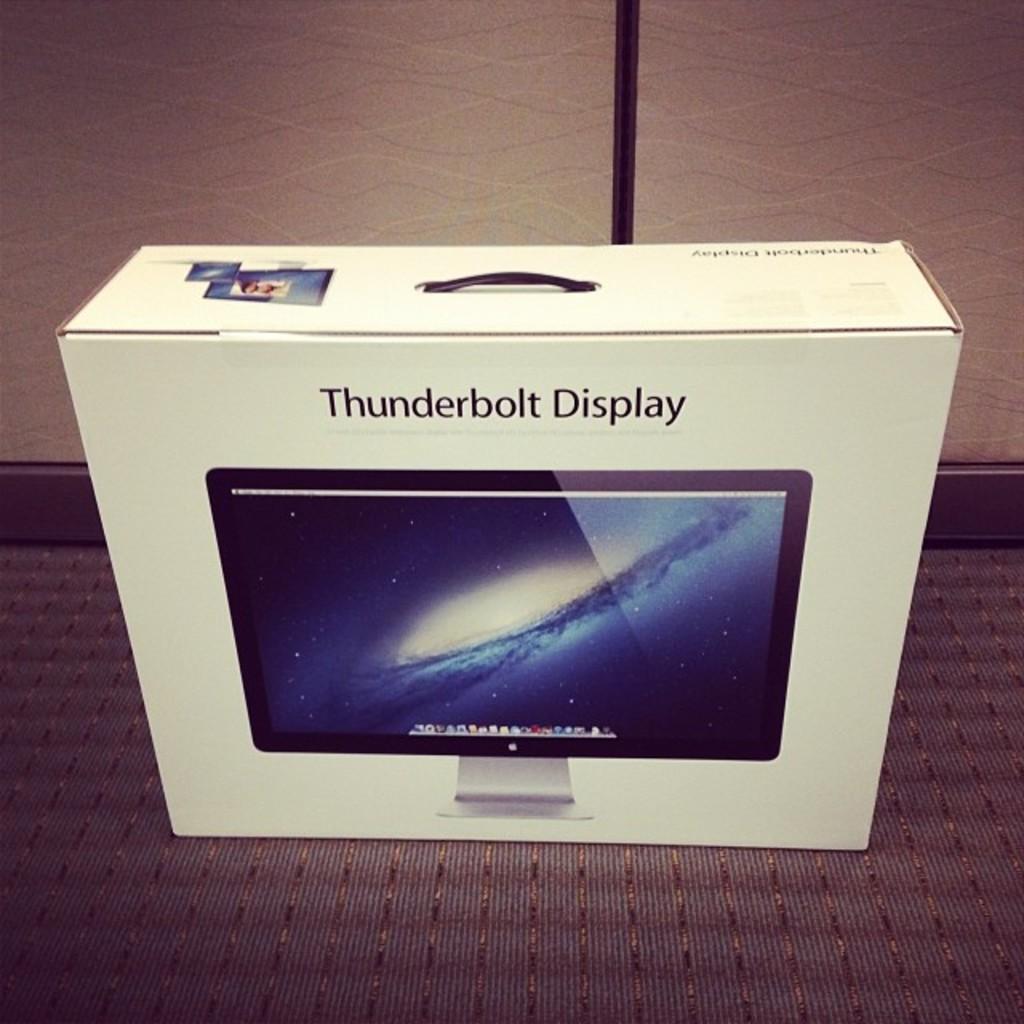What's in the box?
Give a very brief answer. Thunderbolt display. What type of display?
Provide a short and direct response. Thunderbolt. 